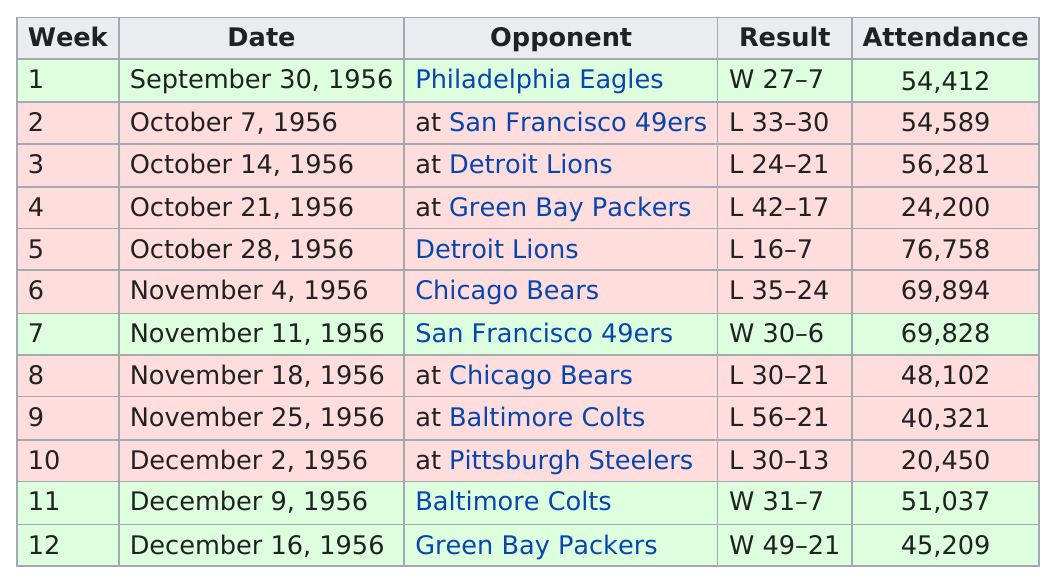Point out several critical features in this image. The Detroit Lions had the largest number of attendees among all opponents. According to historical records, the game held on November 18, 1956 had an attendance of 69,000, besides the one held on November 11, 1956. However, there is no other game date with an attendance of 69,000 people on record. The attendance total on September 30th, 1956 was 54,412. On December 2, 1956, a game was held that had a relatively low attendance of just over 20,000 people. In 1956, the Los Angeles Rams lost eight times. 